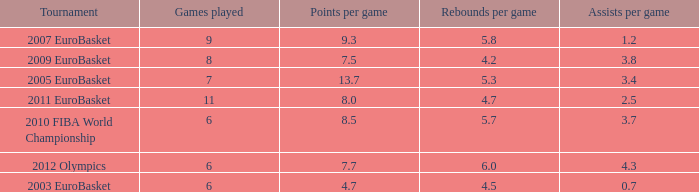How may assists per game have 7.7 points per game? 4.3. 